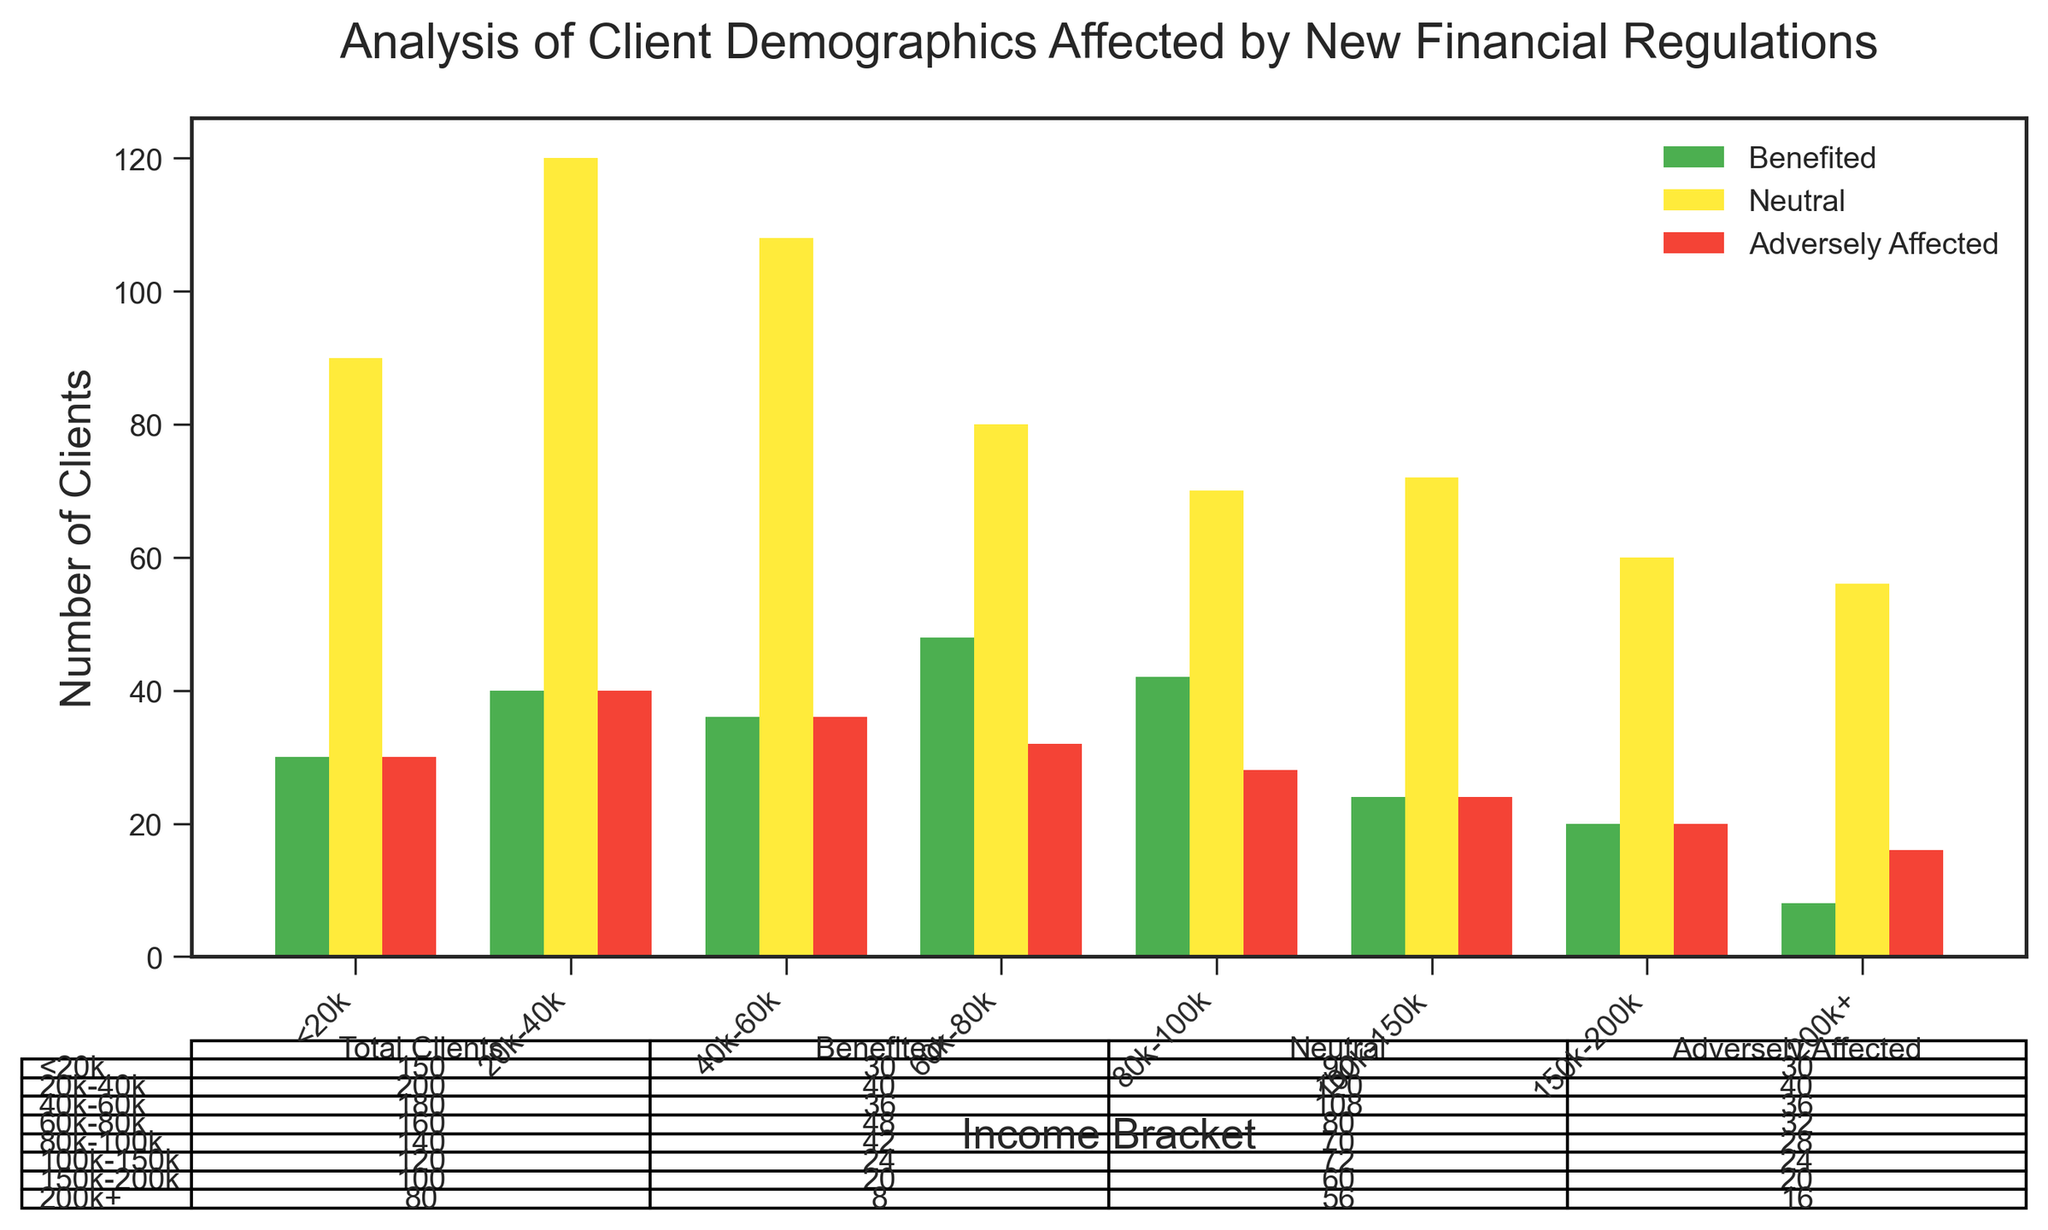Which income bracket has the highest number of clients who benefited? Check the height of the green bars for each income bracket and find the one with the highest value. The 80k-100k bracket has the tallest green bar.
Answer: 80k-100k How many clients are adversely affected in the 60k-80k bracket? Locate the red bar corresponding to the 60k-80k bracket and read its value.
Answer: 32 Compare the number of clients who are neutral in the <20k bracket to those in the 200k+ bracket. Which has more? Check the yellow bars for the <20k and 200k+ brackets and compare their heights/values. The <20k bracket has 90 neutral clients, while the 200k+ bracket has 56.
Answer: <20k What's the total number of clients in the 40k-60k income bracket? Look at the table under the chart and find the total number of clients for the 40k-60k bracket.
Answer: 180 Calculate the difference in the number of clients benefiting in the 20k-40k bracket and the 100k-150k bracket. Identify the green bar values for the 20k-40k and 100k-150k brackets (40 and 24, respectively). Subtract the latter from the former (40 - 24).
Answer: 16 What proportion of clients in the 150k-200k bracket are neutral? Look at the table for the 150k-200k bracket. The number of neutral clients is 60, and the total number of clients is 100. Proportion = 60/100.
Answer: 0.6 Which income bracket has the smallest number of adversely affected clients? Check the red bars for all income brackets and find the one with the smallest value. The 200k+ bracket has the shortest red bar with 16 clients.
Answer: 200k+ How many more clients are neutral in the 80k-100k bracket compared to the 20k-40k bracket? Find the yellow bar values for both brackets (80 and 120, respectively). The difference is
Answer: 80 - 70 What is the total number of clients adversely affected across all income brackets? Sum the numbers from the red bar in each income bracket (30 + 40 + 36 + 32 + 28 + 24 + 20 + 16) = 226.
Answer: 226 